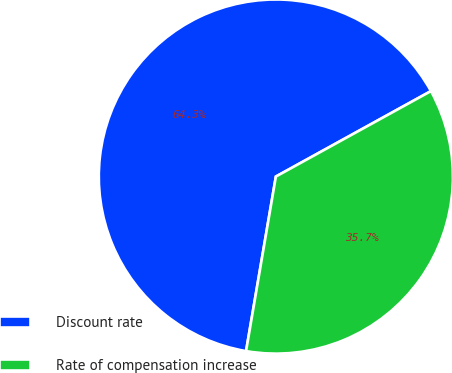Convert chart to OTSL. <chart><loc_0><loc_0><loc_500><loc_500><pie_chart><fcel>Discount rate<fcel>Rate of compensation increase<nl><fcel>64.29%<fcel>35.71%<nl></chart> 